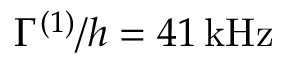Convert formula to latex. <formula><loc_0><loc_0><loc_500><loc_500>\Gamma ^ { ( 1 ) } / h = 4 1 \, { k H z }</formula> 